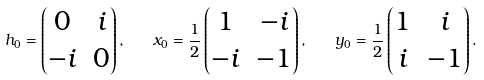Convert formula to latex. <formula><loc_0><loc_0><loc_500><loc_500>h _ { 0 } = \begin{pmatrix} 0 & i \\ - i & 0 \end{pmatrix} , \quad x _ { 0 } = { \frac { 1 } { 2 } } \begin{pmatrix} 1 & - i \\ - i & - 1 \end{pmatrix} , \quad y _ { 0 } = { \frac { 1 } { 2 } } \begin{pmatrix} 1 & i \\ i & - 1 \end{pmatrix} .</formula> 